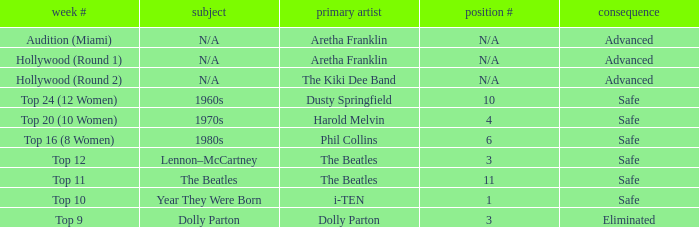What is the order number that has Aretha Franklin as the original artist? N/A, N/A. 